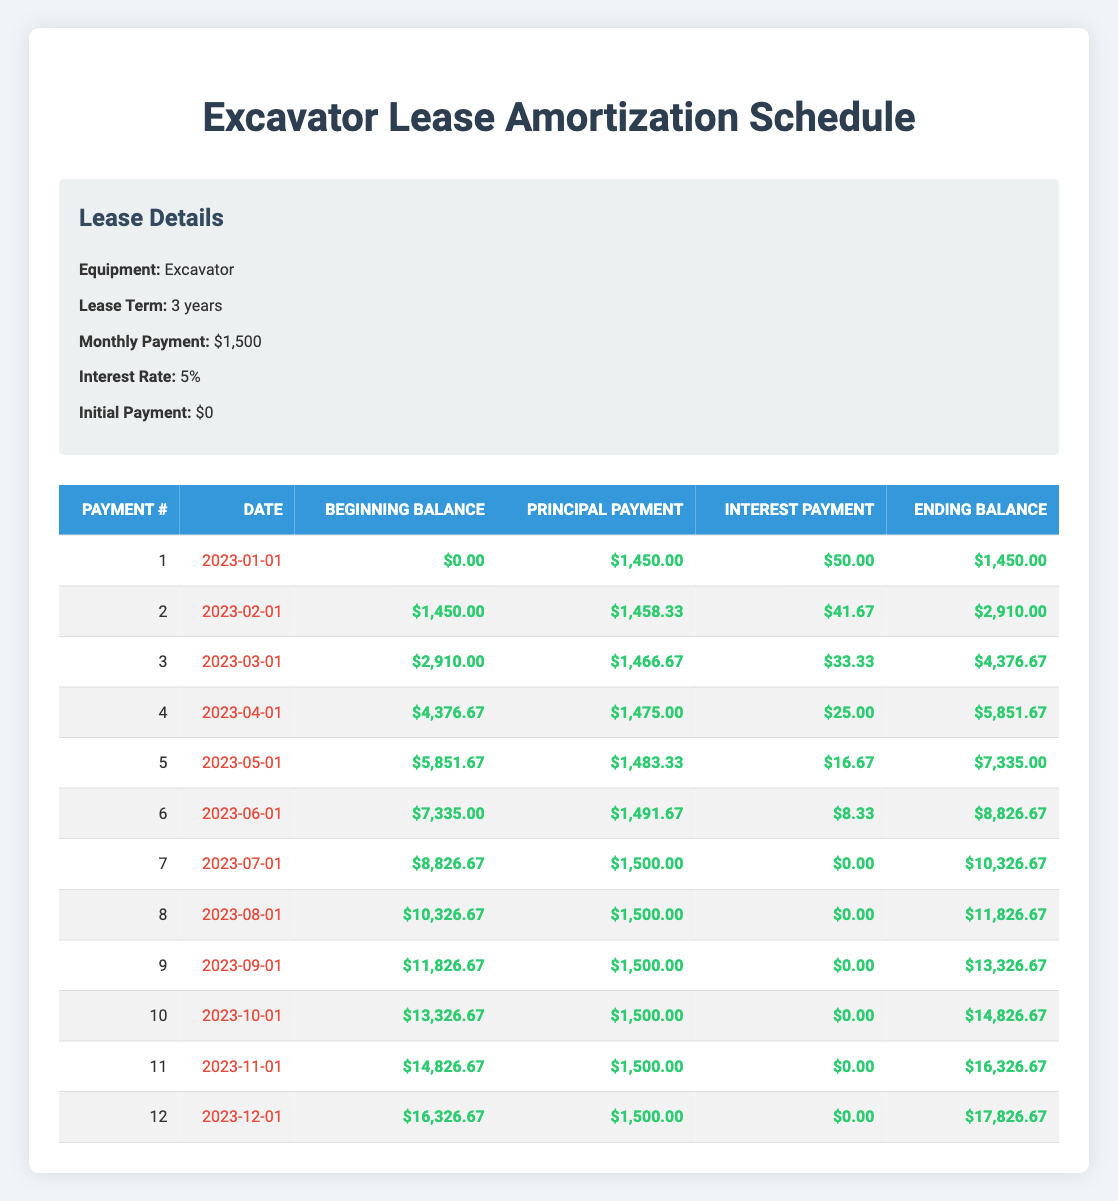What is the monthly payment amount for the equipment lease? The monthly payment amount is the same for each month throughout the lease term, as stated in the lease details section. It is listed as $1,500.
Answer: 1500 What was the principal payment in the first month? The principal payment for the first month is specifically enumerated in the first row of the amortization schedule. It is listed as $1,450.
Answer: 1450 How much interest was paid in total over the first three months? To find the total interest paid over the first three months, we sum the interest payments from the first three months: $50 (month 1) + $41.67 (month 2) + $33.33 (month 3) = $125.00.
Answer: 125 What is the ending balance after the 12th payment? The ending balance after the 12th payment is provided in the last row of the amortization schedule. It shows an ending balance of $17,826.67.
Answer: 17826.67 Is the amount of principal payment in the second month greater than in the first month? By comparing the principal payments from the first month ($1,450) and the second month ($1,458.33), we can see that the second month's principal payment is indeed greater.
Answer: Yes How much did the ending balance increase from the second month to the third month? To find the increase in ending balance from the second month to the third month, we calculate the ending balance of the third month ($4,376.67) minus the second month ($2,910.00). The increase is $4,376.67 - $2,910.00 = $1,466.67.
Answer: 1466.67 What is the average monthly interest payment over the first 12 months? To find the average monthly interest payment, first, sum the interest payments across all 12 months (totaling $50 + $41.67 + $33.33 + $25 + $16.67 + $8.33 + $0 + $0 + $0 + $0 + $0 + $0 = $175.00) and then divide by 12 months to get $175.00 / 12 = $14.58.
Answer: 14.58 Did the principal payment remain consistent after the 6th month? A comparison of principal payments from the 6th month onward reveals they remained constant at $1,500 from the 7th payment through the 12th payment.
Answer: Yes What was the highest principal payment made in any month? The principal payments are listed for each month, and checking through the values indicates that the highest principal payment was the final payments from the 7th month onward, which are all $1,500.
Answer: 1500 